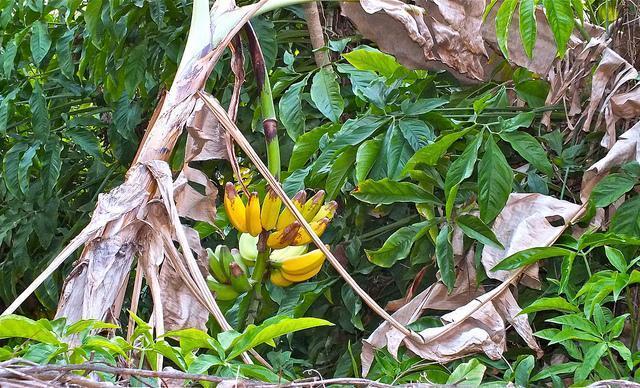How many bananas can you see?
Give a very brief answer. 1. How many girls are there?
Give a very brief answer. 0. 